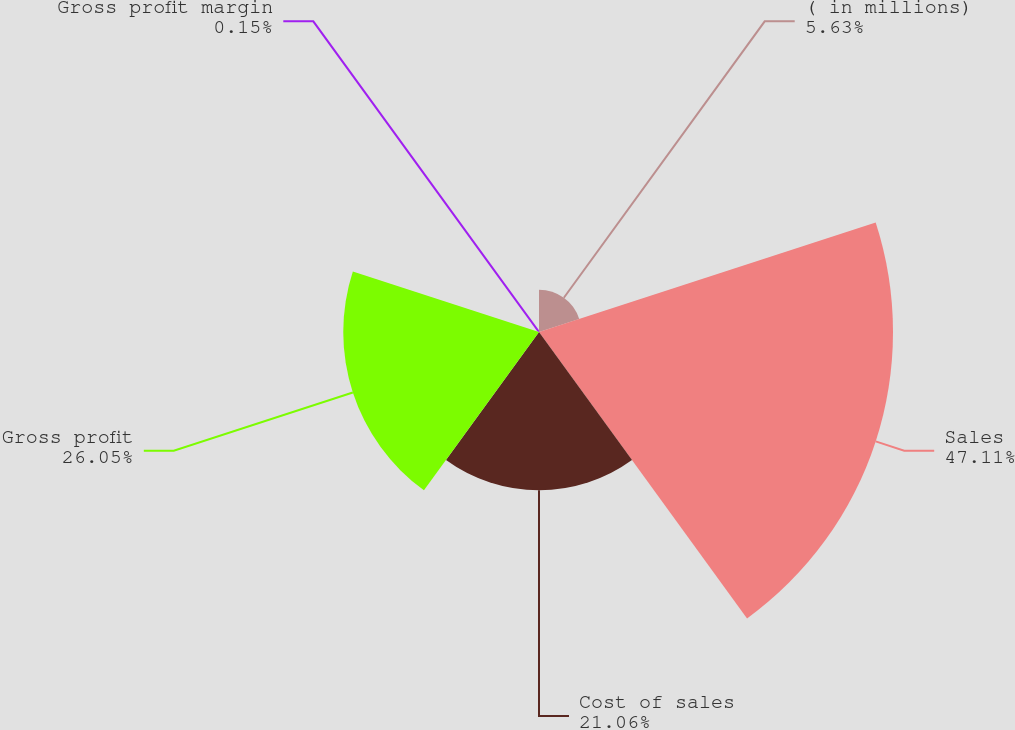Convert chart. <chart><loc_0><loc_0><loc_500><loc_500><pie_chart><fcel>( in millions)<fcel>Sales<fcel>Cost of sales<fcel>Gross profit<fcel>Gross profit margin<nl><fcel>5.63%<fcel>47.11%<fcel>21.06%<fcel>26.05%<fcel>0.15%<nl></chart> 